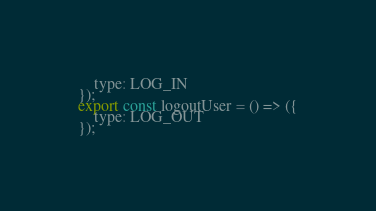<code> <loc_0><loc_0><loc_500><loc_500><_JavaScript_>    type: LOG_IN
});
export const logoutUser = () => ({
    type: LOG_OUT
});</code> 